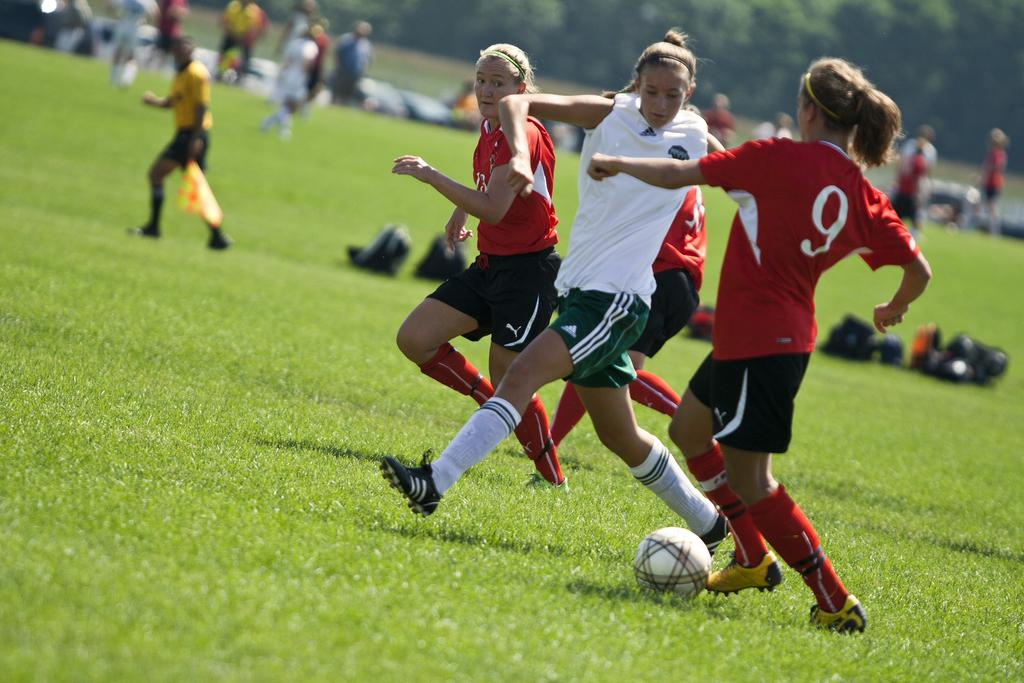<image>
Render a clear and concise summary of the photo. a soccer player with the number 9 on her jersey 